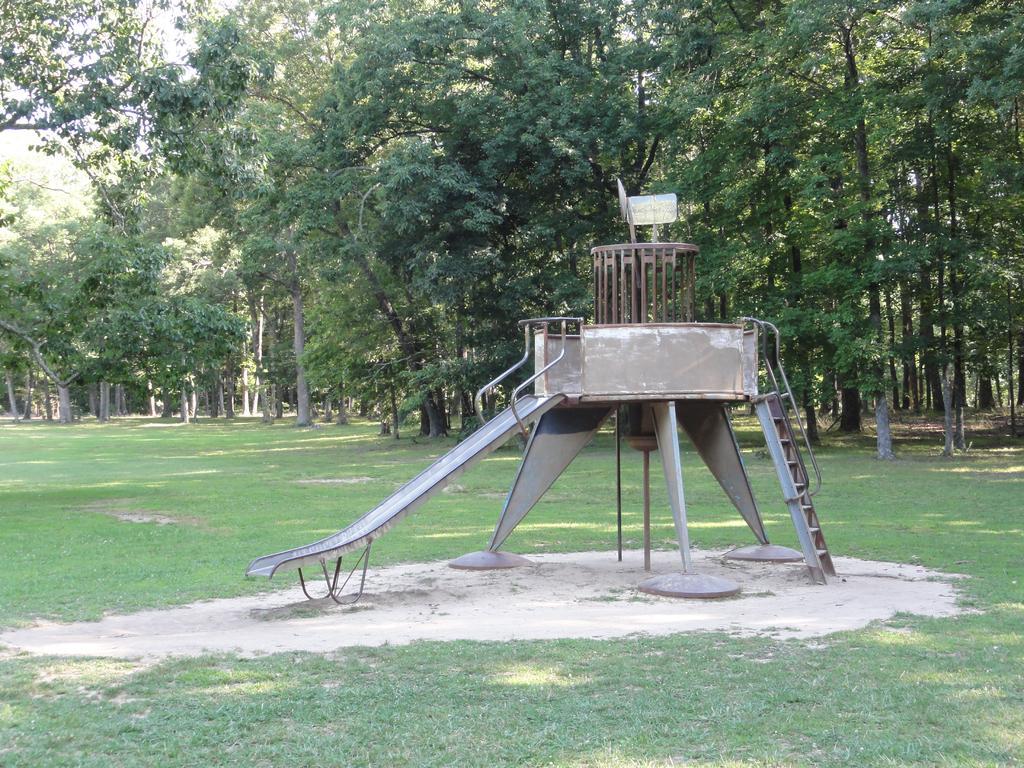Could you give a brief overview of what you see in this image? In the picture I can see slider, a ladder, the grass and some other objects on the ground. In the background I can see trees and sky. 